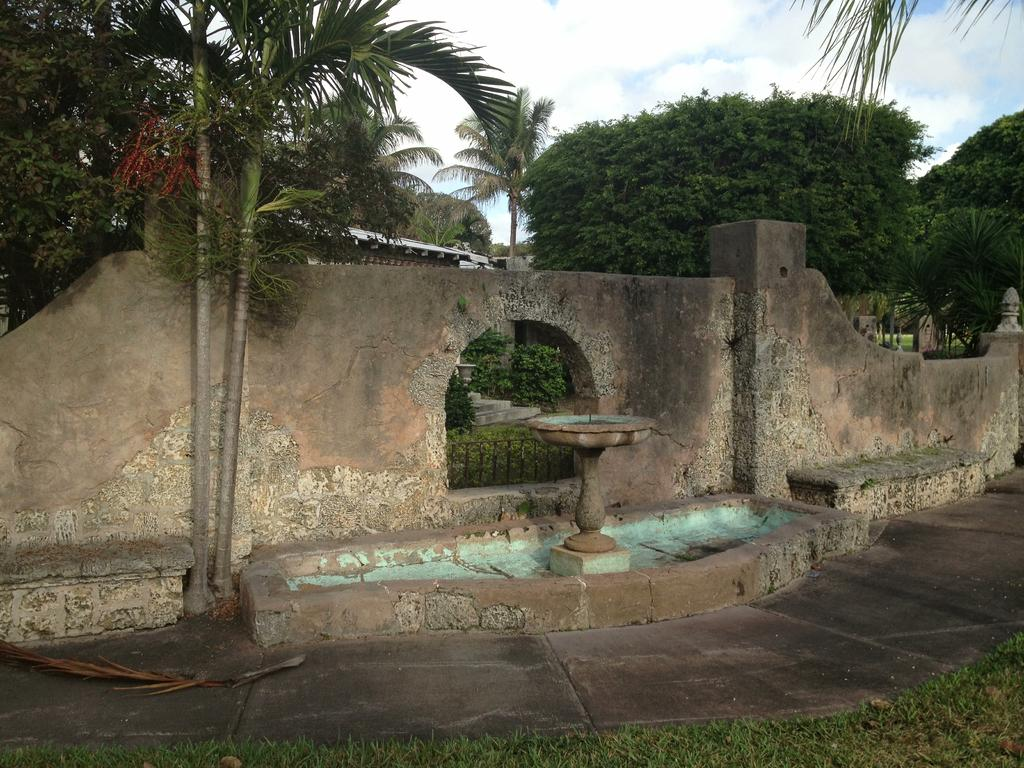What is located in the middle of the picture? There is a wall in the middle of the picture. What can be seen in the background of the picture? There are trees and clouds in the sky in the background of the picture. What type of gold locket is hanging from the tree in the image? There is no gold locket present in the image; it only features a wall, trees, and clouds in the sky. 